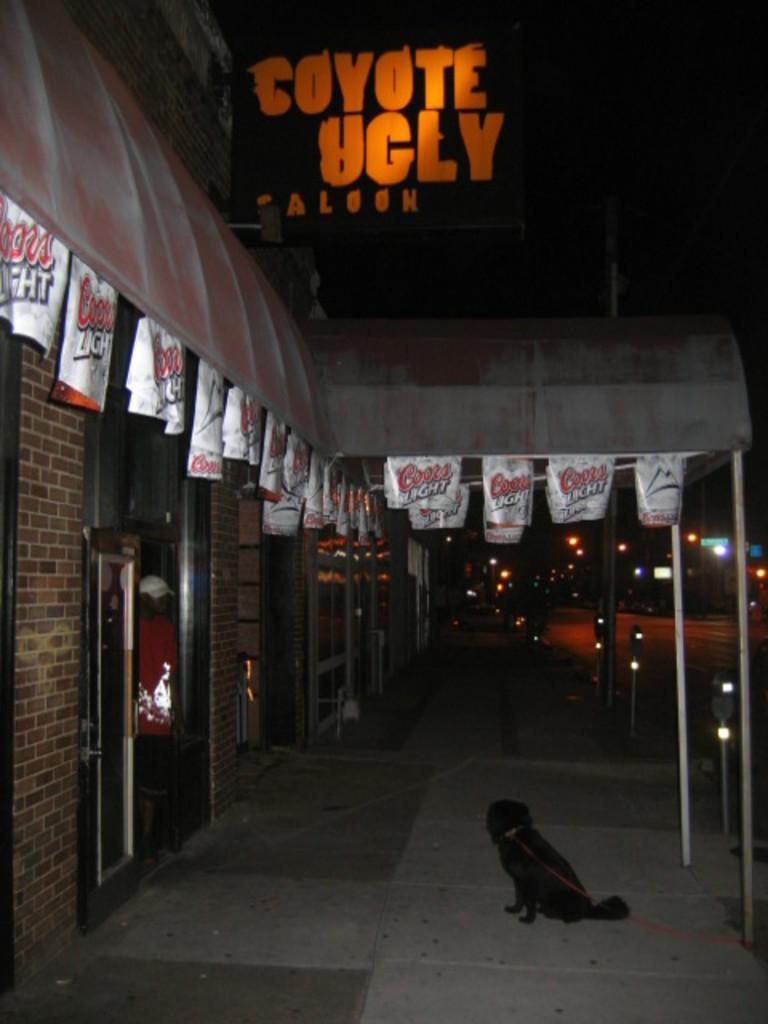Please provide a concise description of this image. In this image I can see a building, door and posters. In the foreground I can see a dog is sitting on the floor. In the background I can see lights, poles, vehicles on the road and the sky. This image is taken may be during night. 